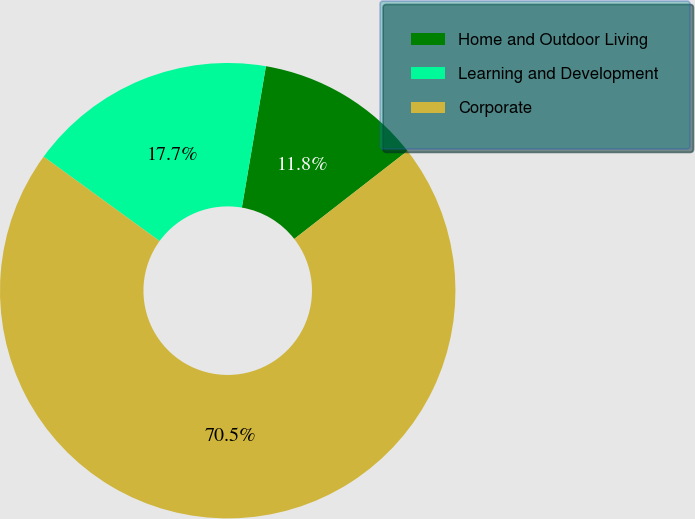Convert chart to OTSL. <chart><loc_0><loc_0><loc_500><loc_500><pie_chart><fcel>Home and Outdoor Living<fcel>Learning and Development<fcel>Corporate<nl><fcel>11.8%<fcel>17.67%<fcel>70.53%<nl></chart> 